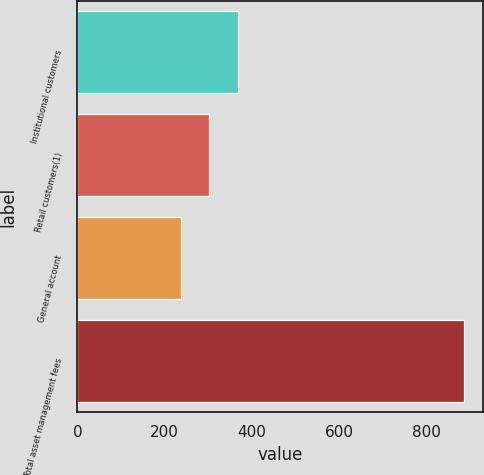Convert chart to OTSL. <chart><loc_0><loc_0><loc_500><loc_500><bar_chart><fcel>Institutional customers<fcel>Retail customers(1)<fcel>General account<fcel>Total asset management fees<nl><fcel>367.6<fcel>302.8<fcel>238<fcel>886<nl></chart> 